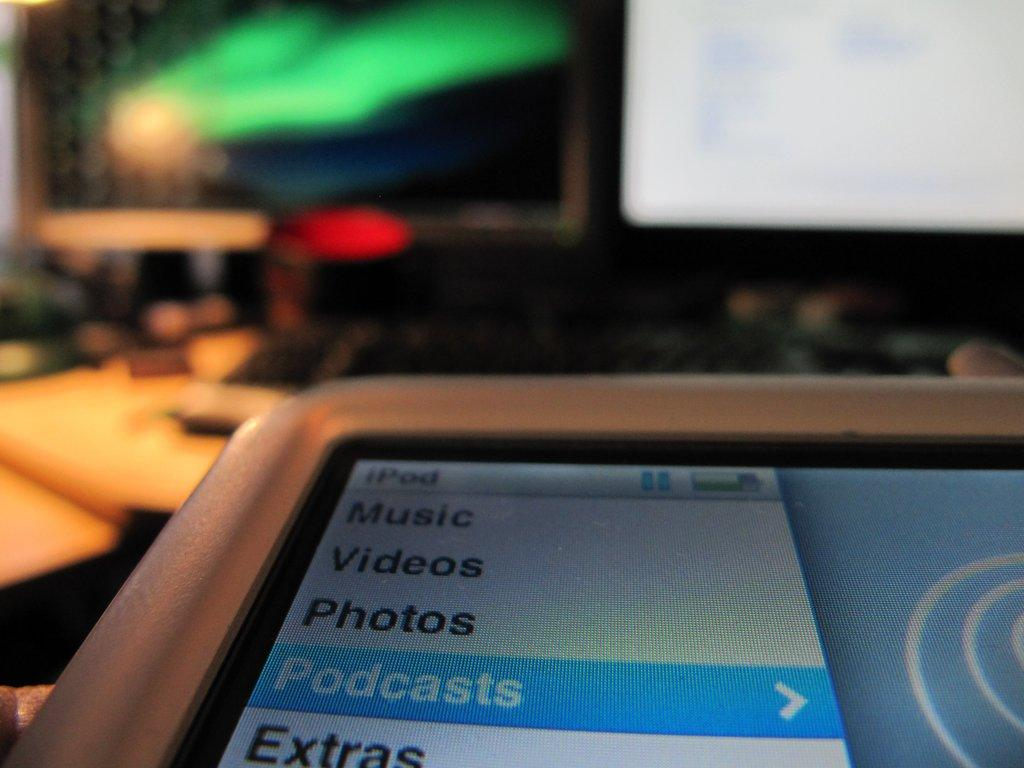<image>
Render a clear and concise summary of the photo. the ipod is powered on and is at podcasts 